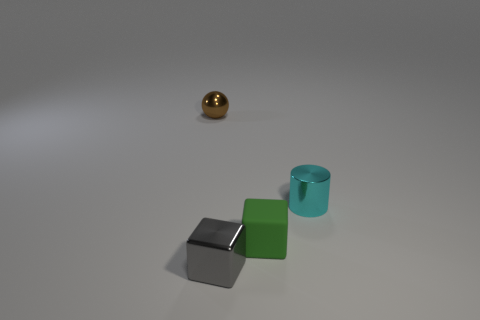Add 3 matte things. How many objects exist? 7 Subtract all cylinders. How many objects are left? 3 Subtract all large shiny spheres. Subtract all tiny blocks. How many objects are left? 2 Add 2 tiny cylinders. How many tiny cylinders are left? 3 Add 3 tiny gray blocks. How many tiny gray blocks exist? 4 Subtract 0 cyan cubes. How many objects are left? 4 